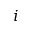Convert formula to latex. <formula><loc_0><loc_0><loc_500><loc_500>i</formula> 